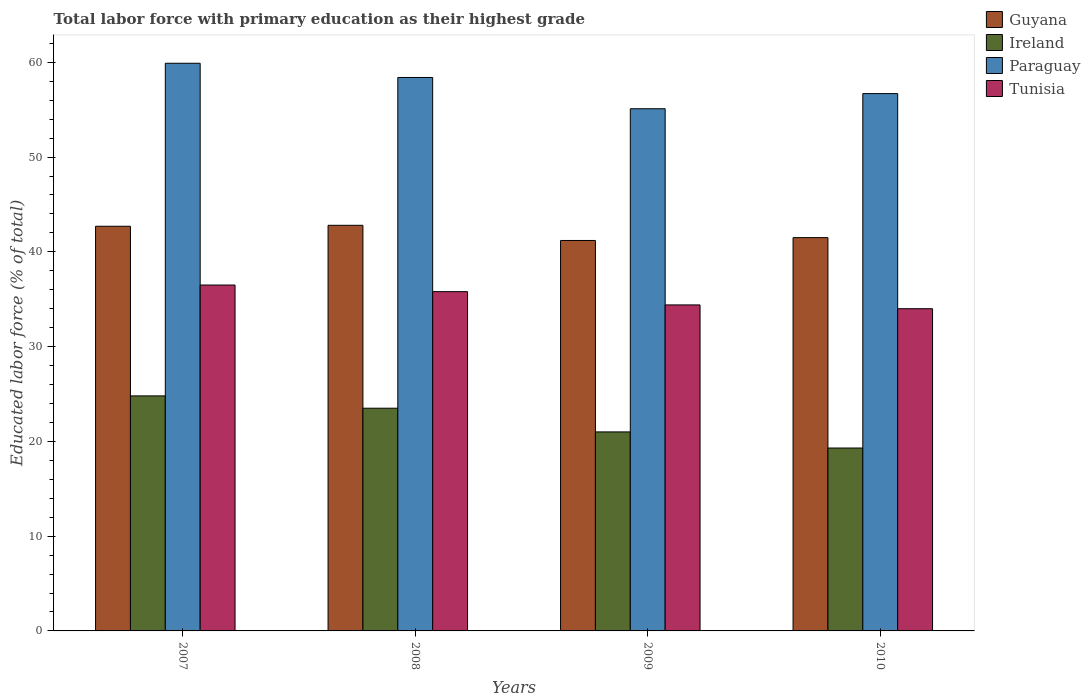How many different coloured bars are there?
Your response must be concise. 4. How many groups of bars are there?
Offer a terse response. 4. How many bars are there on the 3rd tick from the left?
Provide a succinct answer. 4. Across all years, what is the maximum percentage of total labor force with primary education in Guyana?
Offer a terse response. 42.8. Across all years, what is the minimum percentage of total labor force with primary education in Paraguay?
Make the answer very short. 55.1. In which year was the percentage of total labor force with primary education in Ireland maximum?
Your response must be concise. 2007. What is the total percentage of total labor force with primary education in Tunisia in the graph?
Offer a very short reply. 140.7. What is the difference between the percentage of total labor force with primary education in Guyana in 2007 and that in 2008?
Make the answer very short. -0.1. What is the difference between the percentage of total labor force with primary education in Ireland in 2007 and the percentage of total labor force with primary education in Guyana in 2010?
Offer a terse response. -16.7. What is the average percentage of total labor force with primary education in Guyana per year?
Keep it short and to the point. 42.05. In the year 2010, what is the difference between the percentage of total labor force with primary education in Ireland and percentage of total labor force with primary education in Paraguay?
Offer a very short reply. -37.4. In how many years, is the percentage of total labor force with primary education in Tunisia greater than 40 %?
Offer a very short reply. 0. What is the ratio of the percentage of total labor force with primary education in Tunisia in 2008 to that in 2009?
Keep it short and to the point. 1.04. Is the percentage of total labor force with primary education in Ireland in 2007 less than that in 2009?
Give a very brief answer. No. What is the difference between the highest and the second highest percentage of total labor force with primary education in Ireland?
Keep it short and to the point. 1.3. What is the difference between the highest and the lowest percentage of total labor force with primary education in Tunisia?
Offer a terse response. 2.5. Is it the case that in every year, the sum of the percentage of total labor force with primary education in Ireland and percentage of total labor force with primary education in Guyana is greater than the sum of percentage of total labor force with primary education in Paraguay and percentage of total labor force with primary education in Tunisia?
Provide a short and direct response. No. What does the 3rd bar from the left in 2009 represents?
Provide a succinct answer. Paraguay. What does the 1st bar from the right in 2007 represents?
Give a very brief answer. Tunisia. How many bars are there?
Ensure brevity in your answer.  16. Are the values on the major ticks of Y-axis written in scientific E-notation?
Make the answer very short. No. Does the graph contain grids?
Ensure brevity in your answer.  No. Where does the legend appear in the graph?
Give a very brief answer. Top right. How are the legend labels stacked?
Offer a very short reply. Vertical. What is the title of the graph?
Offer a very short reply. Total labor force with primary education as their highest grade. What is the label or title of the Y-axis?
Keep it short and to the point. Educated labor force (% of total). What is the Educated labor force (% of total) of Guyana in 2007?
Give a very brief answer. 42.7. What is the Educated labor force (% of total) in Ireland in 2007?
Make the answer very short. 24.8. What is the Educated labor force (% of total) of Paraguay in 2007?
Make the answer very short. 59.9. What is the Educated labor force (% of total) of Tunisia in 2007?
Make the answer very short. 36.5. What is the Educated labor force (% of total) of Guyana in 2008?
Give a very brief answer. 42.8. What is the Educated labor force (% of total) in Ireland in 2008?
Make the answer very short. 23.5. What is the Educated labor force (% of total) of Paraguay in 2008?
Offer a terse response. 58.4. What is the Educated labor force (% of total) in Tunisia in 2008?
Ensure brevity in your answer.  35.8. What is the Educated labor force (% of total) of Guyana in 2009?
Provide a succinct answer. 41.2. What is the Educated labor force (% of total) in Ireland in 2009?
Your answer should be compact. 21. What is the Educated labor force (% of total) in Paraguay in 2009?
Keep it short and to the point. 55.1. What is the Educated labor force (% of total) in Tunisia in 2009?
Provide a short and direct response. 34.4. What is the Educated labor force (% of total) of Guyana in 2010?
Make the answer very short. 41.5. What is the Educated labor force (% of total) of Ireland in 2010?
Offer a very short reply. 19.3. What is the Educated labor force (% of total) in Paraguay in 2010?
Offer a terse response. 56.7. Across all years, what is the maximum Educated labor force (% of total) of Guyana?
Offer a very short reply. 42.8. Across all years, what is the maximum Educated labor force (% of total) in Ireland?
Give a very brief answer. 24.8. Across all years, what is the maximum Educated labor force (% of total) of Paraguay?
Your response must be concise. 59.9. Across all years, what is the maximum Educated labor force (% of total) in Tunisia?
Ensure brevity in your answer.  36.5. Across all years, what is the minimum Educated labor force (% of total) in Guyana?
Your answer should be compact. 41.2. Across all years, what is the minimum Educated labor force (% of total) of Ireland?
Offer a very short reply. 19.3. Across all years, what is the minimum Educated labor force (% of total) in Paraguay?
Keep it short and to the point. 55.1. What is the total Educated labor force (% of total) of Guyana in the graph?
Your answer should be compact. 168.2. What is the total Educated labor force (% of total) in Ireland in the graph?
Your answer should be compact. 88.6. What is the total Educated labor force (% of total) of Paraguay in the graph?
Your answer should be compact. 230.1. What is the total Educated labor force (% of total) of Tunisia in the graph?
Ensure brevity in your answer.  140.7. What is the difference between the Educated labor force (% of total) of Tunisia in 2007 and that in 2008?
Your response must be concise. 0.7. What is the difference between the Educated labor force (% of total) in Paraguay in 2007 and that in 2009?
Provide a succinct answer. 4.8. What is the difference between the Educated labor force (% of total) in Guyana in 2007 and that in 2010?
Make the answer very short. 1.2. What is the difference between the Educated labor force (% of total) in Paraguay in 2007 and that in 2010?
Make the answer very short. 3.2. What is the difference between the Educated labor force (% of total) of Guyana in 2008 and that in 2009?
Keep it short and to the point. 1.6. What is the difference between the Educated labor force (% of total) in Tunisia in 2008 and that in 2009?
Give a very brief answer. 1.4. What is the difference between the Educated labor force (% of total) of Ireland in 2008 and that in 2010?
Provide a succinct answer. 4.2. What is the difference between the Educated labor force (% of total) in Paraguay in 2008 and that in 2010?
Give a very brief answer. 1.7. What is the difference between the Educated labor force (% of total) in Guyana in 2009 and that in 2010?
Provide a short and direct response. -0.3. What is the difference between the Educated labor force (% of total) of Paraguay in 2009 and that in 2010?
Your answer should be compact. -1.6. What is the difference between the Educated labor force (% of total) of Tunisia in 2009 and that in 2010?
Offer a terse response. 0.4. What is the difference between the Educated labor force (% of total) in Guyana in 2007 and the Educated labor force (% of total) in Ireland in 2008?
Provide a short and direct response. 19.2. What is the difference between the Educated labor force (% of total) of Guyana in 2007 and the Educated labor force (% of total) of Paraguay in 2008?
Give a very brief answer. -15.7. What is the difference between the Educated labor force (% of total) in Guyana in 2007 and the Educated labor force (% of total) in Tunisia in 2008?
Your answer should be very brief. 6.9. What is the difference between the Educated labor force (% of total) of Ireland in 2007 and the Educated labor force (% of total) of Paraguay in 2008?
Provide a short and direct response. -33.6. What is the difference between the Educated labor force (% of total) in Paraguay in 2007 and the Educated labor force (% of total) in Tunisia in 2008?
Ensure brevity in your answer.  24.1. What is the difference between the Educated labor force (% of total) in Guyana in 2007 and the Educated labor force (% of total) in Ireland in 2009?
Provide a short and direct response. 21.7. What is the difference between the Educated labor force (% of total) of Guyana in 2007 and the Educated labor force (% of total) of Paraguay in 2009?
Give a very brief answer. -12.4. What is the difference between the Educated labor force (% of total) in Ireland in 2007 and the Educated labor force (% of total) in Paraguay in 2009?
Provide a succinct answer. -30.3. What is the difference between the Educated labor force (% of total) in Ireland in 2007 and the Educated labor force (% of total) in Tunisia in 2009?
Your answer should be compact. -9.6. What is the difference between the Educated labor force (% of total) of Guyana in 2007 and the Educated labor force (% of total) of Ireland in 2010?
Your answer should be very brief. 23.4. What is the difference between the Educated labor force (% of total) in Guyana in 2007 and the Educated labor force (% of total) in Tunisia in 2010?
Keep it short and to the point. 8.7. What is the difference between the Educated labor force (% of total) in Ireland in 2007 and the Educated labor force (% of total) in Paraguay in 2010?
Provide a succinct answer. -31.9. What is the difference between the Educated labor force (% of total) of Paraguay in 2007 and the Educated labor force (% of total) of Tunisia in 2010?
Provide a short and direct response. 25.9. What is the difference between the Educated labor force (% of total) in Guyana in 2008 and the Educated labor force (% of total) in Ireland in 2009?
Offer a terse response. 21.8. What is the difference between the Educated labor force (% of total) of Ireland in 2008 and the Educated labor force (% of total) of Paraguay in 2009?
Keep it short and to the point. -31.6. What is the difference between the Educated labor force (% of total) in Ireland in 2008 and the Educated labor force (% of total) in Paraguay in 2010?
Provide a short and direct response. -33.2. What is the difference between the Educated labor force (% of total) of Ireland in 2008 and the Educated labor force (% of total) of Tunisia in 2010?
Your answer should be very brief. -10.5. What is the difference between the Educated labor force (% of total) in Paraguay in 2008 and the Educated labor force (% of total) in Tunisia in 2010?
Make the answer very short. 24.4. What is the difference between the Educated labor force (% of total) of Guyana in 2009 and the Educated labor force (% of total) of Ireland in 2010?
Keep it short and to the point. 21.9. What is the difference between the Educated labor force (% of total) in Guyana in 2009 and the Educated labor force (% of total) in Paraguay in 2010?
Keep it short and to the point. -15.5. What is the difference between the Educated labor force (% of total) of Guyana in 2009 and the Educated labor force (% of total) of Tunisia in 2010?
Your answer should be very brief. 7.2. What is the difference between the Educated labor force (% of total) in Ireland in 2009 and the Educated labor force (% of total) in Paraguay in 2010?
Your answer should be compact. -35.7. What is the difference between the Educated labor force (% of total) in Paraguay in 2009 and the Educated labor force (% of total) in Tunisia in 2010?
Offer a terse response. 21.1. What is the average Educated labor force (% of total) of Guyana per year?
Your response must be concise. 42.05. What is the average Educated labor force (% of total) in Ireland per year?
Ensure brevity in your answer.  22.15. What is the average Educated labor force (% of total) in Paraguay per year?
Ensure brevity in your answer.  57.52. What is the average Educated labor force (% of total) in Tunisia per year?
Your answer should be compact. 35.17. In the year 2007, what is the difference between the Educated labor force (% of total) in Guyana and Educated labor force (% of total) in Paraguay?
Offer a very short reply. -17.2. In the year 2007, what is the difference between the Educated labor force (% of total) of Ireland and Educated labor force (% of total) of Paraguay?
Make the answer very short. -35.1. In the year 2007, what is the difference between the Educated labor force (% of total) of Ireland and Educated labor force (% of total) of Tunisia?
Ensure brevity in your answer.  -11.7. In the year 2007, what is the difference between the Educated labor force (% of total) of Paraguay and Educated labor force (% of total) of Tunisia?
Provide a succinct answer. 23.4. In the year 2008, what is the difference between the Educated labor force (% of total) of Guyana and Educated labor force (% of total) of Ireland?
Ensure brevity in your answer.  19.3. In the year 2008, what is the difference between the Educated labor force (% of total) of Guyana and Educated labor force (% of total) of Paraguay?
Ensure brevity in your answer.  -15.6. In the year 2008, what is the difference between the Educated labor force (% of total) in Ireland and Educated labor force (% of total) in Paraguay?
Your answer should be very brief. -34.9. In the year 2008, what is the difference between the Educated labor force (% of total) of Ireland and Educated labor force (% of total) of Tunisia?
Make the answer very short. -12.3. In the year 2008, what is the difference between the Educated labor force (% of total) in Paraguay and Educated labor force (% of total) in Tunisia?
Your answer should be very brief. 22.6. In the year 2009, what is the difference between the Educated labor force (% of total) in Guyana and Educated labor force (% of total) in Ireland?
Your response must be concise. 20.2. In the year 2009, what is the difference between the Educated labor force (% of total) of Ireland and Educated labor force (% of total) of Paraguay?
Your answer should be very brief. -34.1. In the year 2009, what is the difference between the Educated labor force (% of total) of Ireland and Educated labor force (% of total) of Tunisia?
Your answer should be compact. -13.4. In the year 2009, what is the difference between the Educated labor force (% of total) in Paraguay and Educated labor force (% of total) in Tunisia?
Make the answer very short. 20.7. In the year 2010, what is the difference between the Educated labor force (% of total) in Guyana and Educated labor force (% of total) in Ireland?
Give a very brief answer. 22.2. In the year 2010, what is the difference between the Educated labor force (% of total) of Guyana and Educated labor force (% of total) of Paraguay?
Provide a short and direct response. -15.2. In the year 2010, what is the difference between the Educated labor force (% of total) in Ireland and Educated labor force (% of total) in Paraguay?
Give a very brief answer. -37.4. In the year 2010, what is the difference between the Educated labor force (% of total) of Ireland and Educated labor force (% of total) of Tunisia?
Your answer should be very brief. -14.7. In the year 2010, what is the difference between the Educated labor force (% of total) in Paraguay and Educated labor force (% of total) in Tunisia?
Ensure brevity in your answer.  22.7. What is the ratio of the Educated labor force (% of total) in Ireland in 2007 to that in 2008?
Provide a short and direct response. 1.06. What is the ratio of the Educated labor force (% of total) in Paraguay in 2007 to that in 2008?
Make the answer very short. 1.03. What is the ratio of the Educated labor force (% of total) of Tunisia in 2007 to that in 2008?
Your answer should be very brief. 1.02. What is the ratio of the Educated labor force (% of total) of Guyana in 2007 to that in 2009?
Offer a very short reply. 1.04. What is the ratio of the Educated labor force (% of total) in Ireland in 2007 to that in 2009?
Give a very brief answer. 1.18. What is the ratio of the Educated labor force (% of total) in Paraguay in 2007 to that in 2009?
Ensure brevity in your answer.  1.09. What is the ratio of the Educated labor force (% of total) of Tunisia in 2007 to that in 2009?
Your response must be concise. 1.06. What is the ratio of the Educated labor force (% of total) of Guyana in 2007 to that in 2010?
Your response must be concise. 1.03. What is the ratio of the Educated labor force (% of total) in Ireland in 2007 to that in 2010?
Make the answer very short. 1.28. What is the ratio of the Educated labor force (% of total) of Paraguay in 2007 to that in 2010?
Make the answer very short. 1.06. What is the ratio of the Educated labor force (% of total) in Tunisia in 2007 to that in 2010?
Your answer should be compact. 1.07. What is the ratio of the Educated labor force (% of total) in Guyana in 2008 to that in 2009?
Keep it short and to the point. 1.04. What is the ratio of the Educated labor force (% of total) of Ireland in 2008 to that in 2009?
Provide a succinct answer. 1.12. What is the ratio of the Educated labor force (% of total) in Paraguay in 2008 to that in 2009?
Your response must be concise. 1.06. What is the ratio of the Educated labor force (% of total) in Tunisia in 2008 to that in 2009?
Offer a very short reply. 1.04. What is the ratio of the Educated labor force (% of total) of Guyana in 2008 to that in 2010?
Your answer should be very brief. 1.03. What is the ratio of the Educated labor force (% of total) in Ireland in 2008 to that in 2010?
Your answer should be compact. 1.22. What is the ratio of the Educated labor force (% of total) in Paraguay in 2008 to that in 2010?
Your response must be concise. 1.03. What is the ratio of the Educated labor force (% of total) of Tunisia in 2008 to that in 2010?
Provide a short and direct response. 1.05. What is the ratio of the Educated labor force (% of total) of Ireland in 2009 to that in 2010?
Offer a very short reply. 1.09. What is the ratio of the Educated labor force (% of total) in Paraguay in 2009 to that in 2010?
Give a very brief answer. 0.97. What is the ratio of the Educated labor force (% of total) in Tunisia in 2009 to that in 2010?
Your answer should be very brief. 1.01. What is the difference between the highest and the second highest Educated labor force (% of total) of Guyana?
Your answer should be compact. 0.1. What is the difference between the highest and the second highest Educated labor force (% of total) of Ireland?
Your answer should be very brief. 1.3. What is the difference between the highest and the second highest Educated labor force (% of total) of Paraguay?
Provide a succinct answer. 1.5. What is the difference between the highest and the lowest Educated labor force (% of total) in Ireland?
Offer a terse response. 5.5. What is the difference between the highest and the lowest Educated labor force (% of total) of Paraguay?
Your response must be concise. 4.8. What is the difference between the highest and the lowest Educated labor force (% of total) of Tunisia?
Make the answer very short. 2.5. 